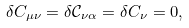Convert formula to latex. <formula><loc_0><loc_0><loc_500><loc_500>\delta C _ { \mu \nu } = \delta \mathcal { C } _ { \nu \alpha } = \delta C _ { \nu } = 0 ,</formula> 